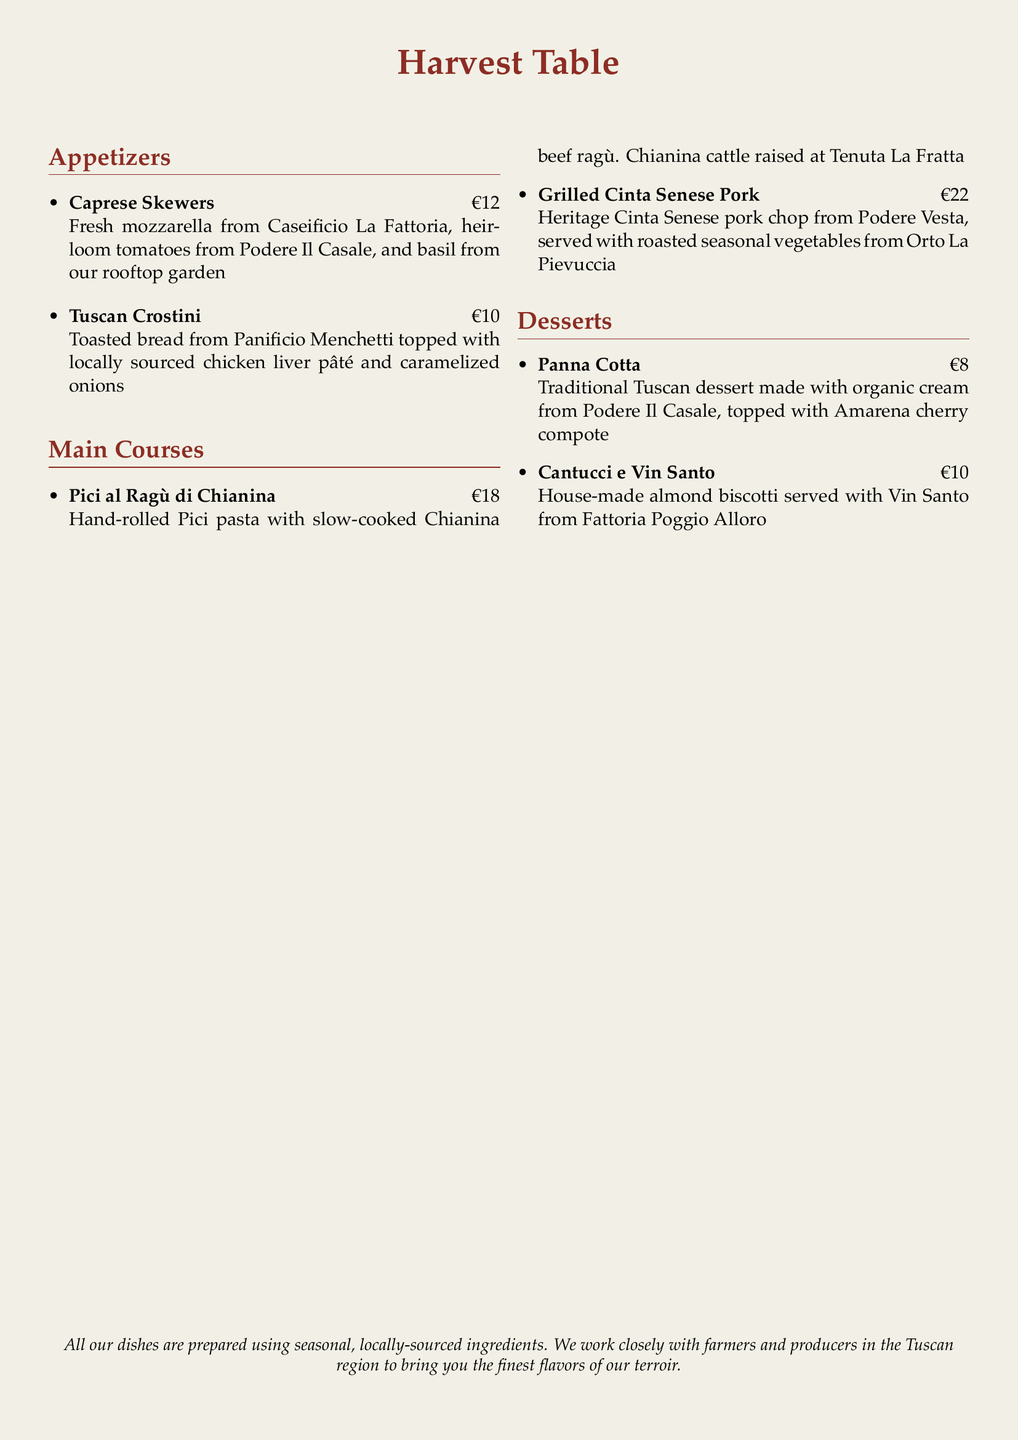What is the name of the restaurant? The name of the restaurant is highlighted at the top of the menu in a larger font.
Answer: Harvest Table How much do the Caprese Skewers cost? The price of the Caprese Skewers is listed next to the item in euros.
Answer: €12 Where is the mozzarella from? The origin of the mozzarella is specified in the description of the Caprese Skewers.
Answer: Caseificio La Fattoria What type of pasta is used in the main course? The type of pasta is identified in the description of the main course Pici al Ragù di Chianina.
Answer: Pici What is the main protein in the Grilled Cinta Senese Pork dish? The main protein is highlighted in the dish description for Grilled Cinta Senese Pork.
Answer: Cinta Senese pork How much is the dessert Panna Cotta? The price of the dessert Panna Cotta is mentioned in euros next to the item.
Answer: €8 What is unique about the Cantucci e Vin Santo? The Cantucci e Vin Santo is a type of dessert served with a specific drink, noted in the description.
Answer: House-made almond biscotti What type of cream is used in the Panna Cotta? The type of cream is specified in the description of Panna Cotta.
Answer: Organic cream Which farm is mentioned for the seasonal vegetables? The source of the seasonal vegetables is stated in the description of the main course with Cinta Senese Pork.
Answer: Orto La Pievuccia 